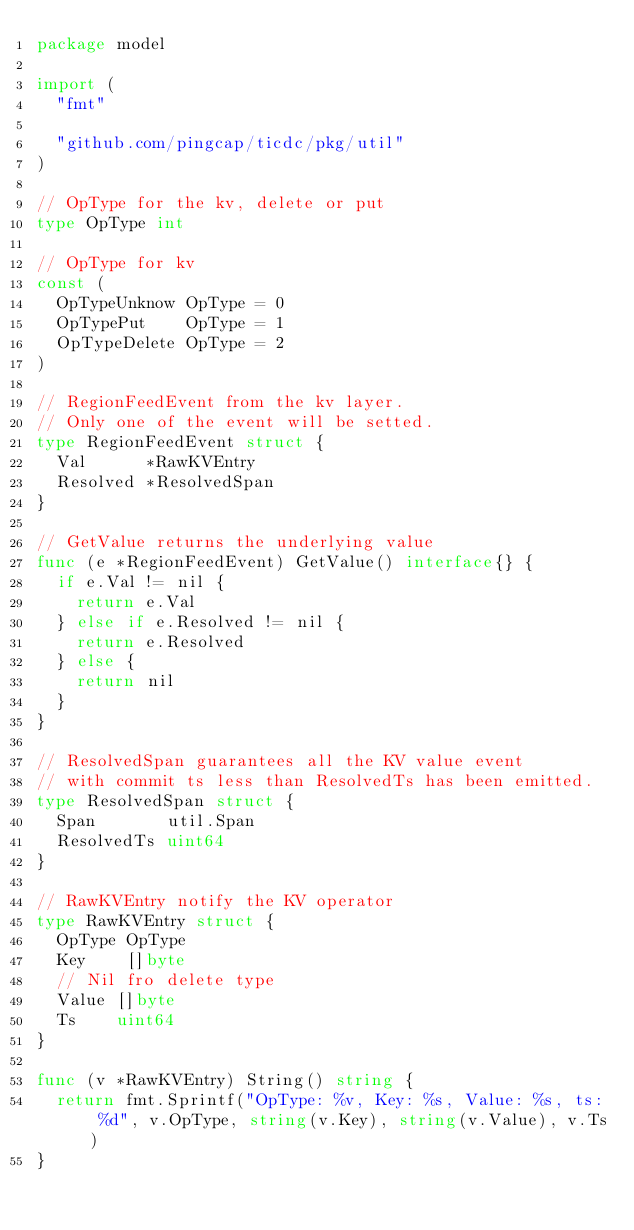Convert code to text. <code><loc_0><loc_0><loc_500><loc_500><_Go_>package model

import (
	"fmt"

	"github.com/pingcap/ticdc/pkg/util"
)

// OpType for the kv, delete or put
type OpType int

// OpType for kv
const (
	OpTypeUnknow OpType = 0
	OpTypePut    OpType = 1
	OpTypeDelete OpType = 2
)

// RegionFeedEvent from the kv layer.
// Only one of the event will be setted.
type RegionFeedEvent struct {
	Val      *RawKVEntry
	Resolved *ResolvedSpan
}

// GetValue returns the underlying value
func (e *RegionFeedEvent) GetValue() interface{} {
	if e.Val != nil {
		return e.Val
	} else if e.Resolved != nil {
		return e.Resolved
	} else {
		return nil
	}
}

// ResolvedSpan guarantees all the KV value event
// with commit ts less than ResolvedTs has been emitted.
type ResolvedSpan struct {
	Span       util.Span
	ResolvedTs uint64
}

// RawKVEntry notify the KV operator
type RawKVEntry struct {
	OpType OpType
	Key    []byte
	// Nil fro delete type
	Value []byte
	Ts    uint64
}

func (v *RawKVEntry) String() string {
	return fmt.Sprintf("OpType: %v, Key: %s, Value: %s, ts: %d", v.OpType, string(v.Key), string(v.Value), v.Ts)
}
</code> 